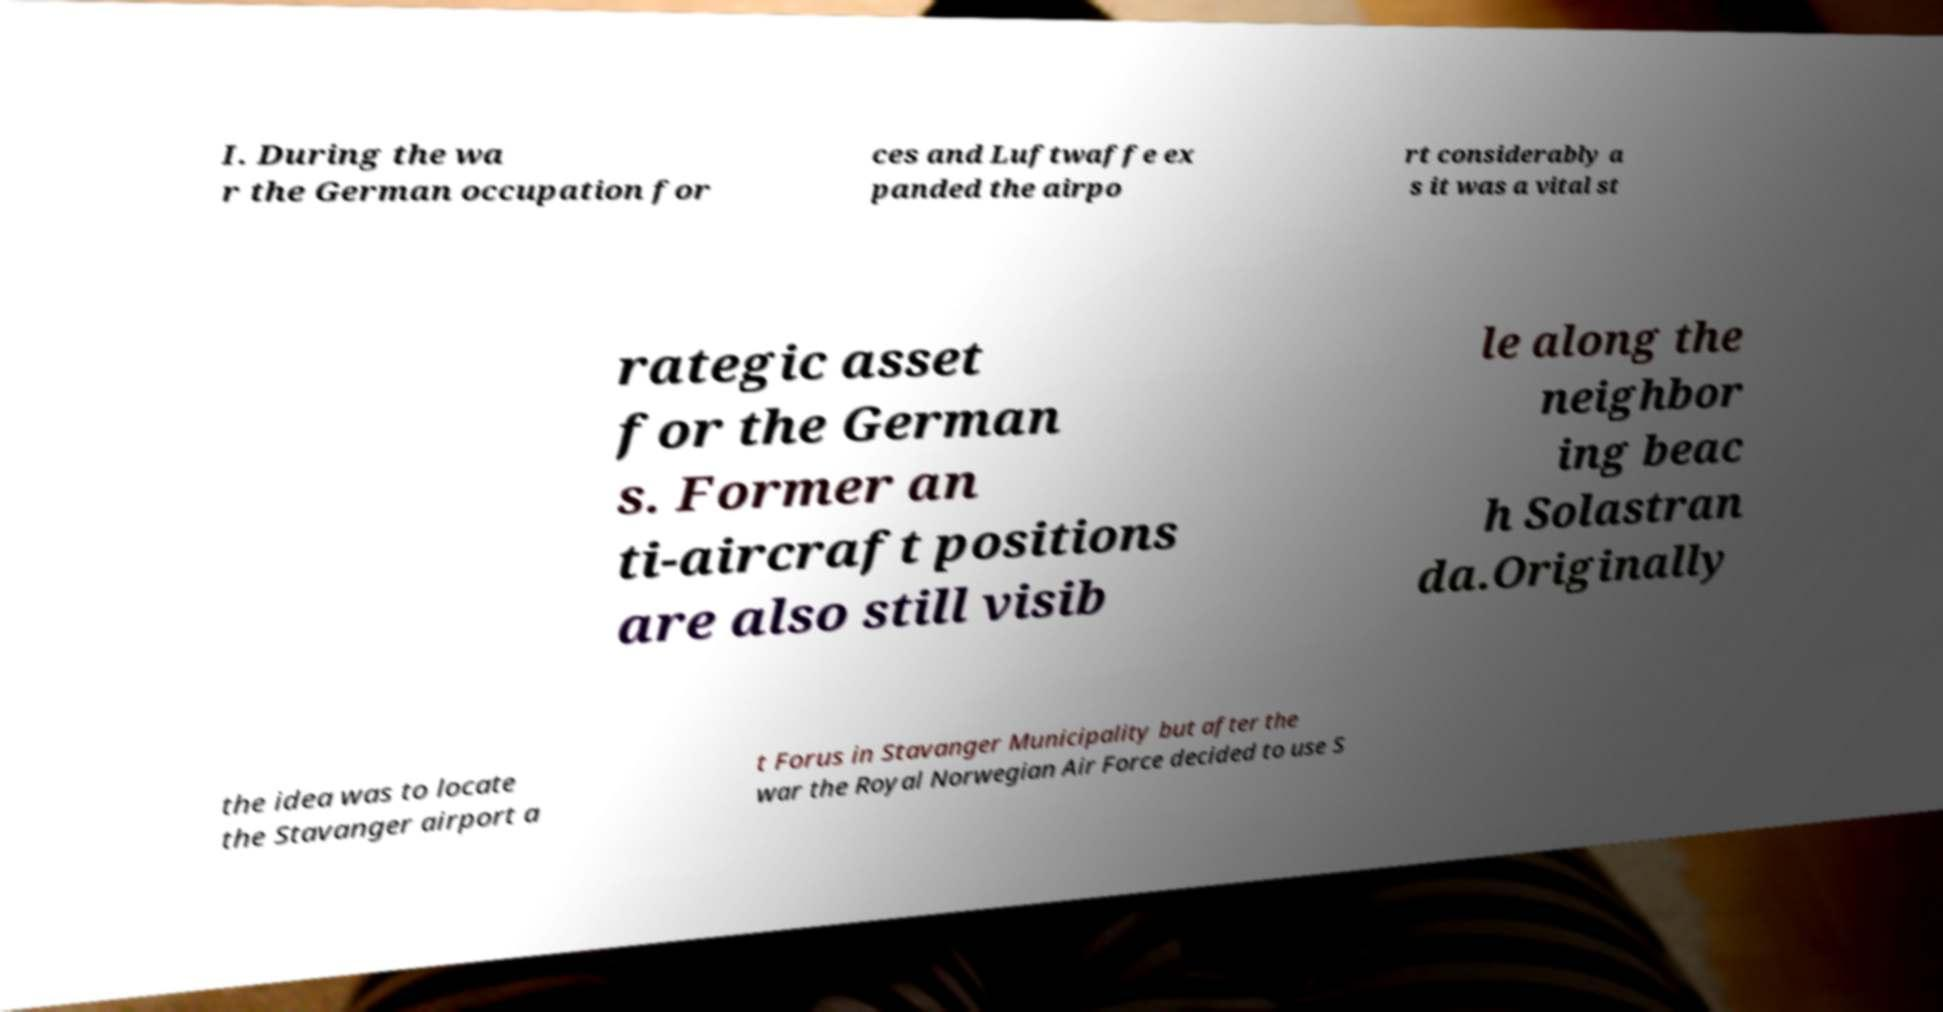For documentation purposes, I need the text within this image transcribed. Could you provide that? I. During the wa r the German occupation for ces and Luftwaffe ex panded the airpo rt considerably a s it was a vital st rategic asset for the German s. Former an ti-aircraft positions are also still visib le along the neighbor ing beac h Solastran da.Originally the idea was to locate the Stavanger airport a t Forus in Stavanger Municipality but after the war the Royal Norwegian Air Force decided to use S 